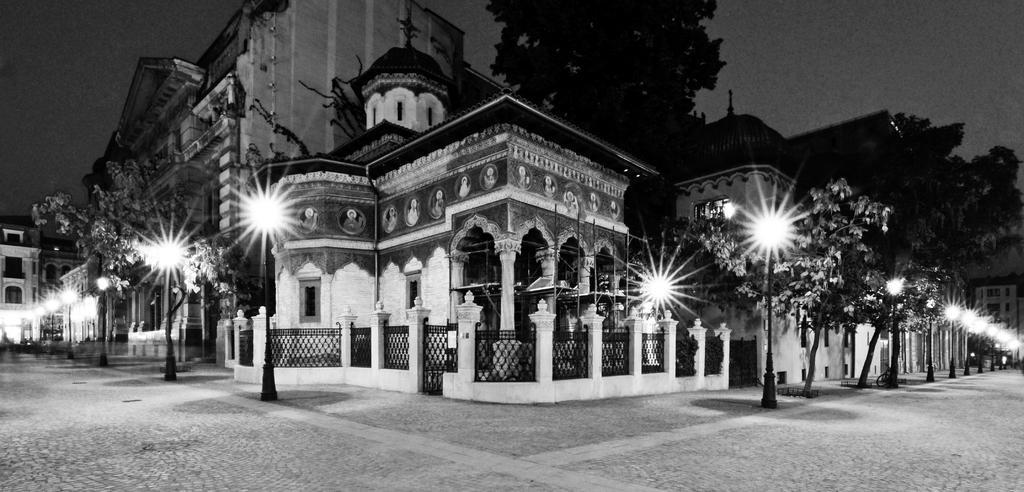Describe this image in one or two sentences. In this image we can see buildings, trees, poles and lights. In the background there is sky. 